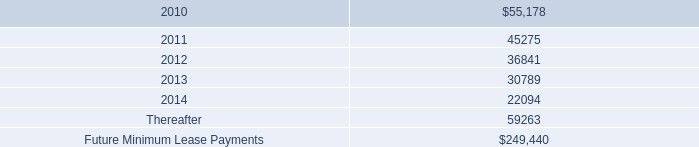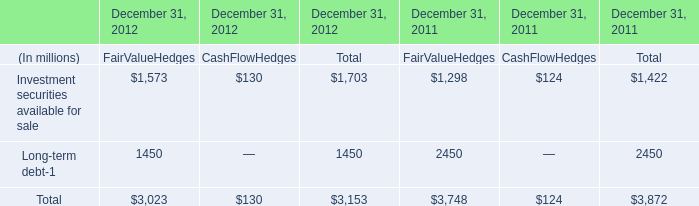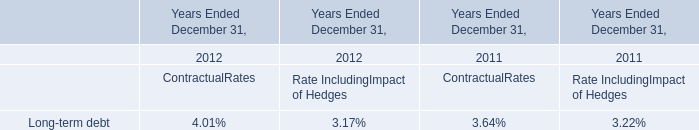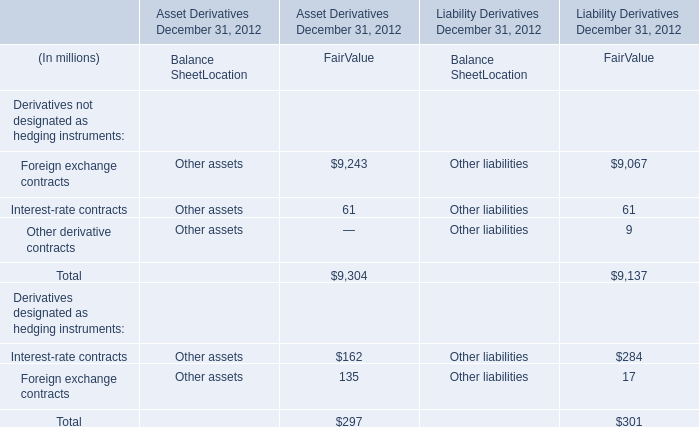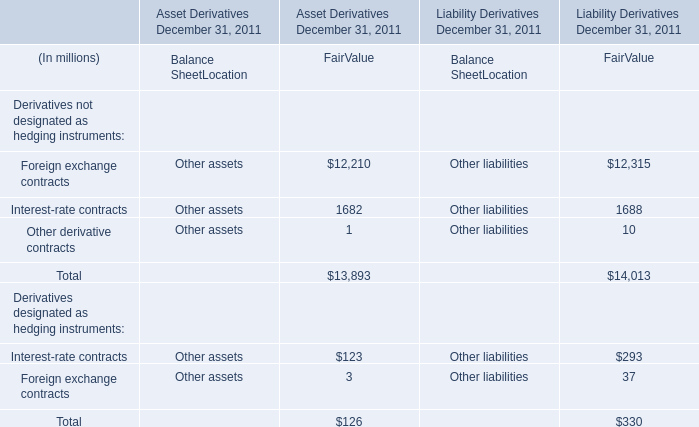Which year is Foreign exchange contracts the most for FairValue? 
Answer: Liability Derivatives December 31, 2011. 